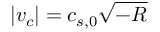Convert formula to latex. <formula><loc_0><loc_0><loc_500><loc_500>| v _ { c } | = c _ { s , 0 } \sqrt { - R }</formula> 